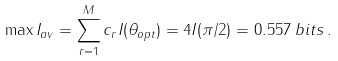<formula> <loc_0><loc_0><loc_500><loc_500>\max I _ { a v } = \sum _ { r = 1 } ^ { M } { c _ { r } I ( \theta _ { o p t } ) } = 4 I ( \pi / 2 ) = 0 . 5 5 7 \, b i t s \, .</formula> 